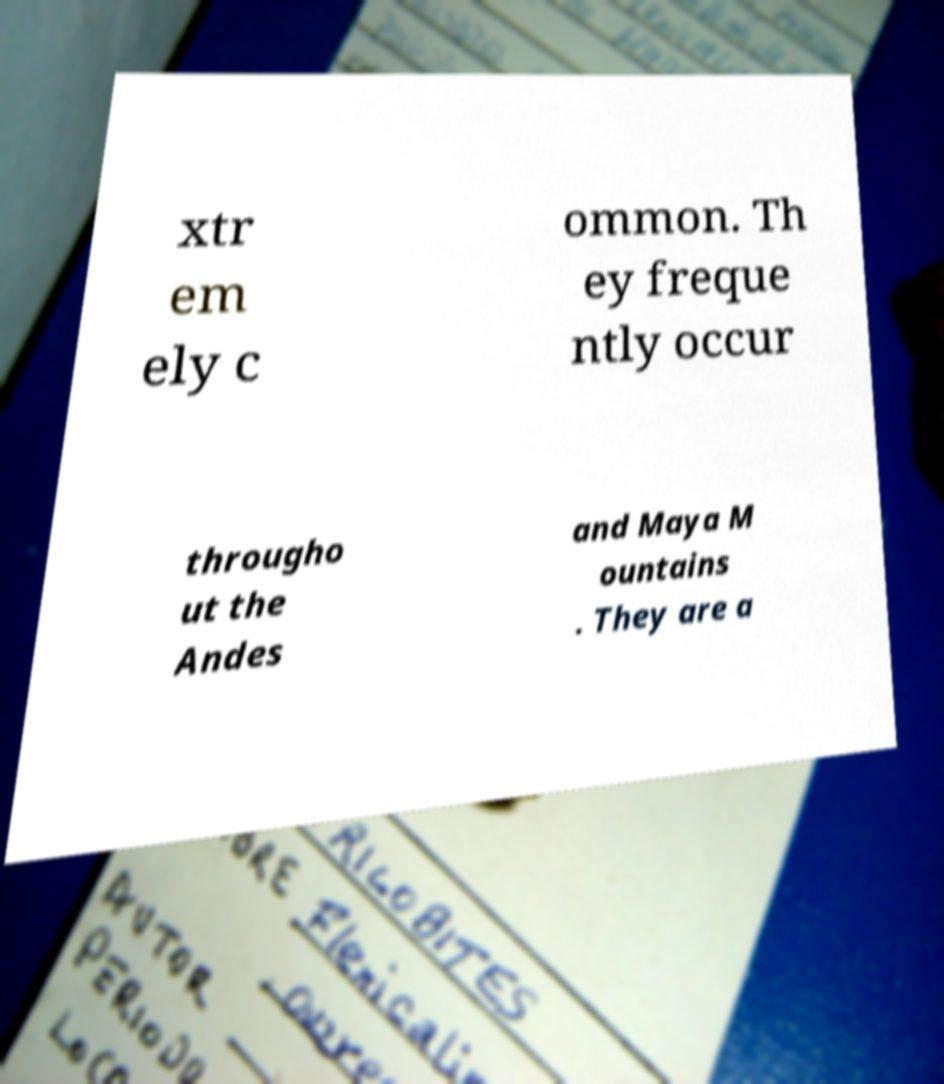I need the written content from this picture converted into text. Can you do that? xtr em ely c ommon. Th ey freque ntly occur througho ut the Andes and Maya M ountains . They are a 